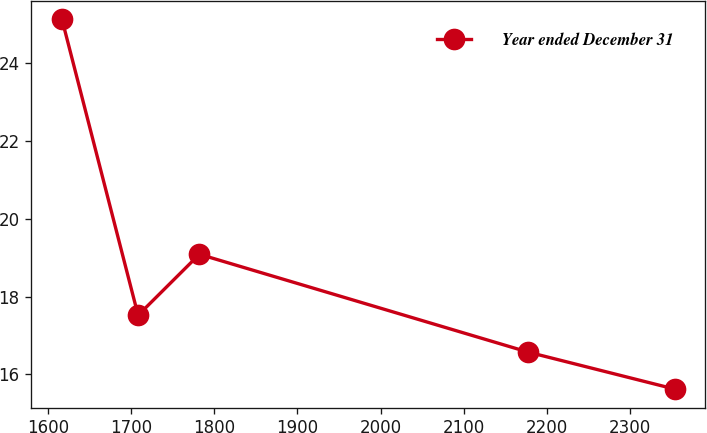Convert chart. <chart><loc_0><loc_0><loc_500><loc_500><line_chart><ecel><fcel>Year ended December 31<nl><fcel>1616.96<fcel>25.14<nl><fcel>1708.55<fcel>17.52<nl><fcel>1782.24<fcel>19.09<nl><fcel>2177.86<fcel>16.57<nl><fcel>2353.87<fcel>15.62<nl></chart> 